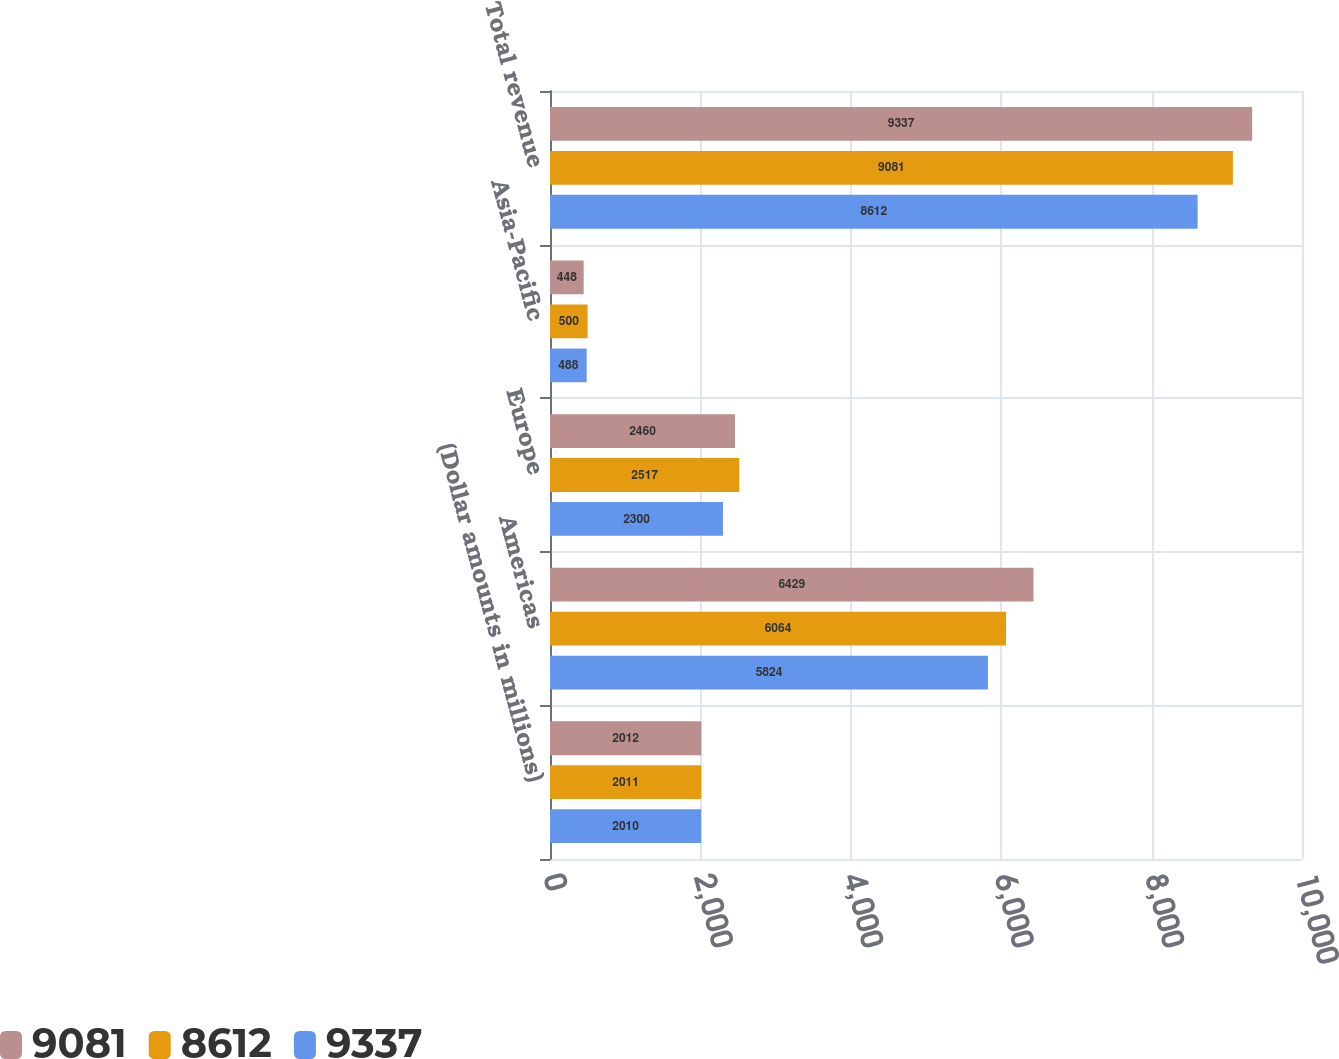Convert chart. <chart><loc_0><loc_0><loc_500><loc_500><stacked_bar_chart><ecel><fcel>(Dollar amounts in millions)<fcel>Americas<fcel>Europe<fcel>Asia-Pacific<fcel>Total revenue<nl><fcel>9081<fcel>2012<fcel>6429<fcel>2460<fcel>448<fcel>9337<nl><fcel>8612<fcel>2011<fcel>6064<fcel>2517<fcel>500<fcel>9081<nl><fcel>9337<fcel>2010<fcel>5824<fcel>2300<fcel>488<fcel>8612<nl></chart> 